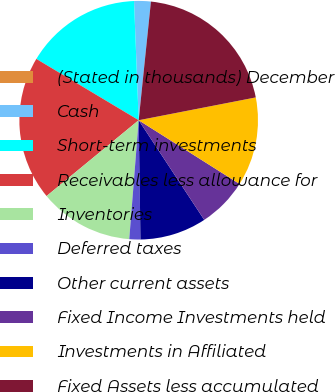Convert chart. <chart><loc_0><loc_0><loc_500><loc_500><pie_chart><fcel>(Stated in thousands) December<fcel>Cash<fcel>Short-term investments<fcel>Receivables less allowance for<fcel>Inventories<fcel>Deferred taxes<fcel>Other current assets<fcel>Fixed Income Investments held<fcel>Investments in Affiliated<fcel>Fixed Assets less accumulated<nl><fcel>0.0%<fcel>2.26%<fcel>15.79%<fcel>19.55%<fcel>12.78%<fcel>1.5%<fcel>9.02%<fcel>6.77%<fcel>12.03%<fcel>20.3%<nl></chart> 